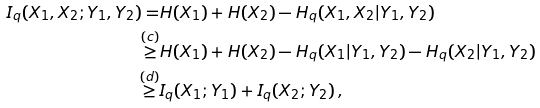<formula> <loc_0><loc_0><loc_500><loc_500>I _ { q } ( X _ { 1 } , X _ { 2 } ; Y _ { 1 } , Y _ { 2 } ) = & H ( X _ { 1 } ) + H ( X _ { 2 } ) - H _ { q } ( X _ { 1 } , X _ { 2 } | Y _ { 1 } , Y _ { 2 } ) \\ \stackrel { ( c ) } { \geq } & H ( X _ { 1 } ) + H ( X _ { 2 } ) - H _ { q } ( X _ { 1 } | Y _ { 1 } , Y _ { 2 } ) - H _ { q } ( X _ { 2 } | Y _ { 1 } , Y _ { 2 } ) \\ \stackrel { ( d ) } { \geq } & I _ { q } ( X _ { 1 } ; Y _ { 1 } ) + I _ { q } ( X _ { 2 } ; Y _ { 2 } ) \, ,</formula> 